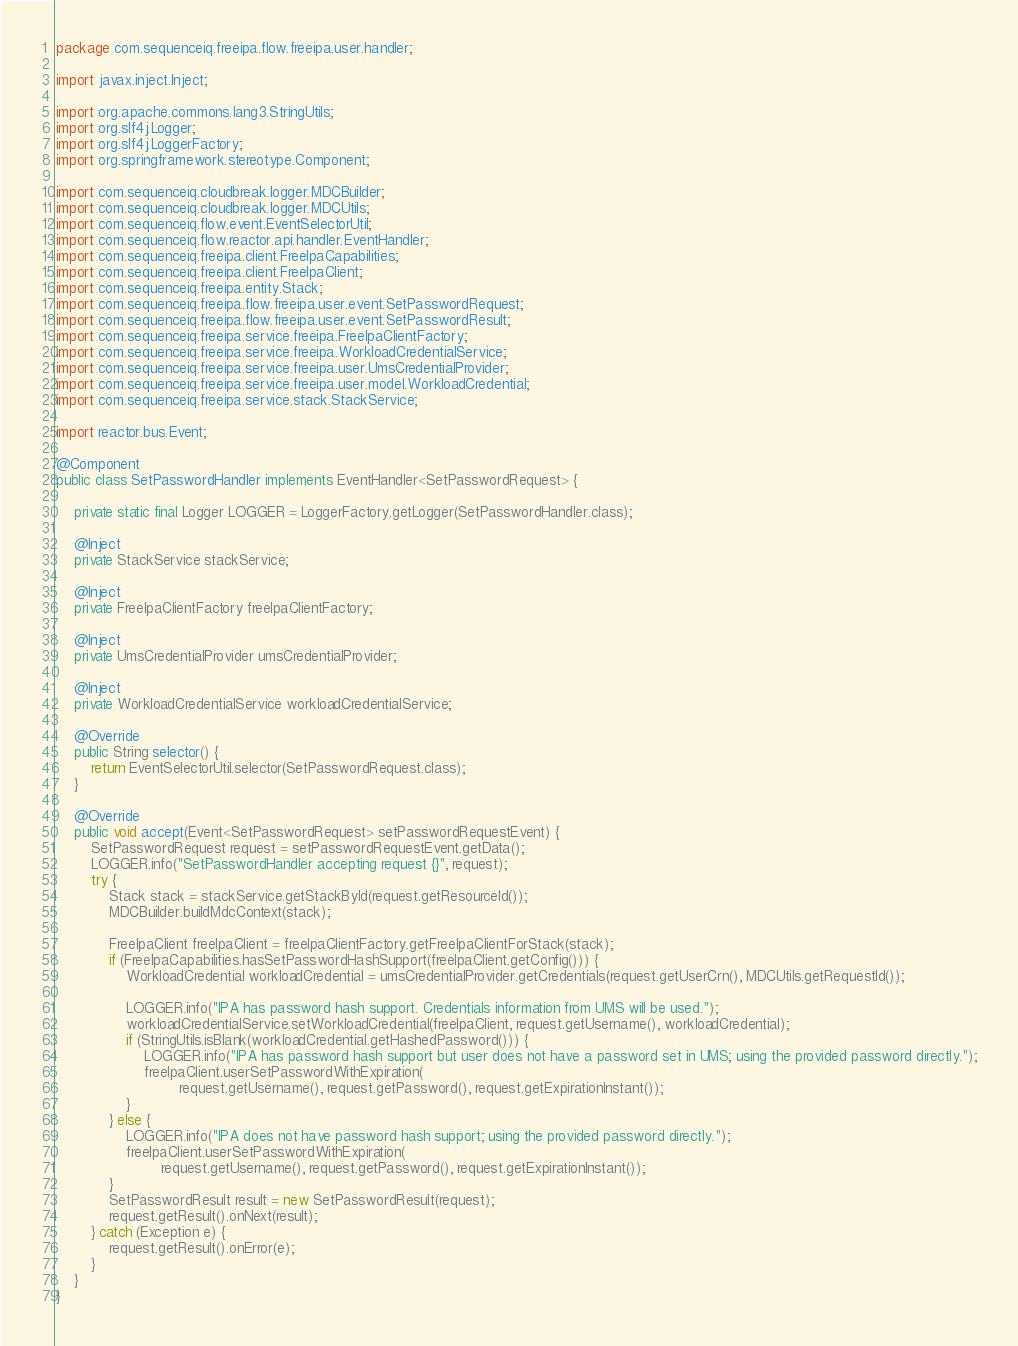<code> <loc_0><loc_0><loc_500><loc_500><_Java_>package com.sequenceiq.freeipa.flow.freeipa.user.handler;

import javax.inject.Inject;

import org.apache.commons.lang3.StringUtils;
import org.slf4j.Logger;
import org.slf4j.LoggerFactory;
import org.springframework.stereotype.Component;

import com.sequenceiq.cloudbreak.logger.MDCBuilder;
import com.sequenceiq.cloudbreak.logger.MDCUtils;
import com.sequenceiq.flow.event.EventSelectorUtil;
import com.sequenceiq.flow.reactor.api.handler.EventHandler;
import com.sequenceiq.freeipa.client.FreeIpaCapabilities;
import com.sequenceiq.freeipa.client.FreeIpaClient;
import com.sequenceiq.freeipa.entity.Stack;
import com.sequenceiq.freeipa.flow.freeipa.user.event.SetPasswordRequest;
import com.sequenceiq.freeipa.flow.freeipa.user.event.SetPasswordResult;
import com.sequenceiq.freeipa.service.freeipa.FreeIpaClientFactory;
import com.sequenceiq.freeipa.service.freeipa.WorkloadCredentialService;
import com.sequenceiq.freeipa.service.freeipa.user.UmsCredentialProvider;
import com.sequenceiq.freeipa.service.freeipa.user.model.WorkloadCredential;
import com.sequenceiq.freeipa.service.stack.StackService;

import reactor.bus.Event;

@Component
public class SetPasswordHandler implements EventHandler<SetPasswordRequest> {

    private static final Logger LOGGER = LoggerFactory.getLogger(SetPasswordHandler.class);

    @Inject
    private StackService stackService;

    @Inject
    private FreeIpaClientFactory freeIpaClientFactory;

    @Inject
    private UmsCredentialProvider umsCredentialProvider;

    @Inject
    private WorkloadCredentialService workloadCredentialService;

    @Override
    public String selector() {
        return EventSelectorUtil.selector(SetPasswordRequest.class);
    }

    @Override
    public void accept(Event<SetPasswordRequest> setPasswordRequestEvent) {
        SetPasswordRequest request = setPasswordRequestEvent.getData();
        LOGGER.info("SetPasswordHandler accepting request {}", request);
        try {
            Stack stack = stackService.getStackById(request.getResourceId());
            MDCBuilder.buildMdcContext(stack);

            FreeIpaClient freeIpaClient = freeIpaClientFactory.getFreeIpaClientForStack(stack);
            if (FreeIpaCapabilities.hasSetPasswordHashSupport(freeIpaClient.getConfig())) {
                WorkloadCredential workloadCredential = umsCredentialProvider.getCredentials(request.getUserCrn(), MDCUtils.getRequestId());

                LOGGER.info("IPA has password hash support. Credentials information from UMS will be used.");
                workloadCredentialService.setWorkloadCredential(freeIpaClient, request.getUsername(), workloadCredential);
                if (StringUtils.isBlank(workloadCredential.getHashedPassword())) {
                    LOGGER.info("IPA has password hash support but user does not have a password set in UMS; using the provided password directly.");
                    freeIpaClient.userSetPasswordWithExpiration(
                            request.getUsername(), request.getPassword(), request.getExpirationInstant());
                }
            } else {
                LOGGER.info("IPA does not have password hash support; using the provided password directly.");
                freeIpaClient.userSetPasswordWithExpiration(
                        request.getUsername(), request.getPassword(), request.getExpirationInstant());
            }
            SetPasswordResult result = new SetPasswordResult(request);
            request.getResult().onNext(result);
        } catch (Exception e) {
            request.getResult().onError(e);
        }
    }
}</code> 